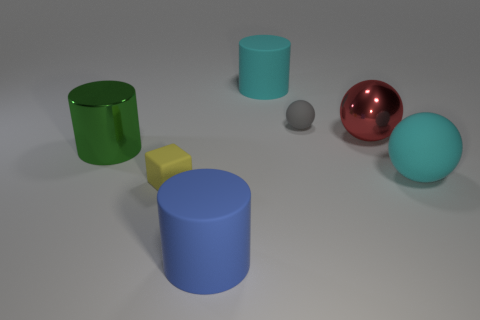Suppose these objects had to interact with one another, which two do you think would be most interesting to observe? If these objects were to interact, observing the red metallic sphere roll towards the blue cylinder could be quite intriguing, as the sphere's reflective surface would distort the surrounding reflections while it moved, perhaps even showing a distorted reflection of the cylinder itself. It would also be interesting to see if the sphere would be able to knock over the cylinder or just roll around it, giving us insight into their relative weights and stability. 